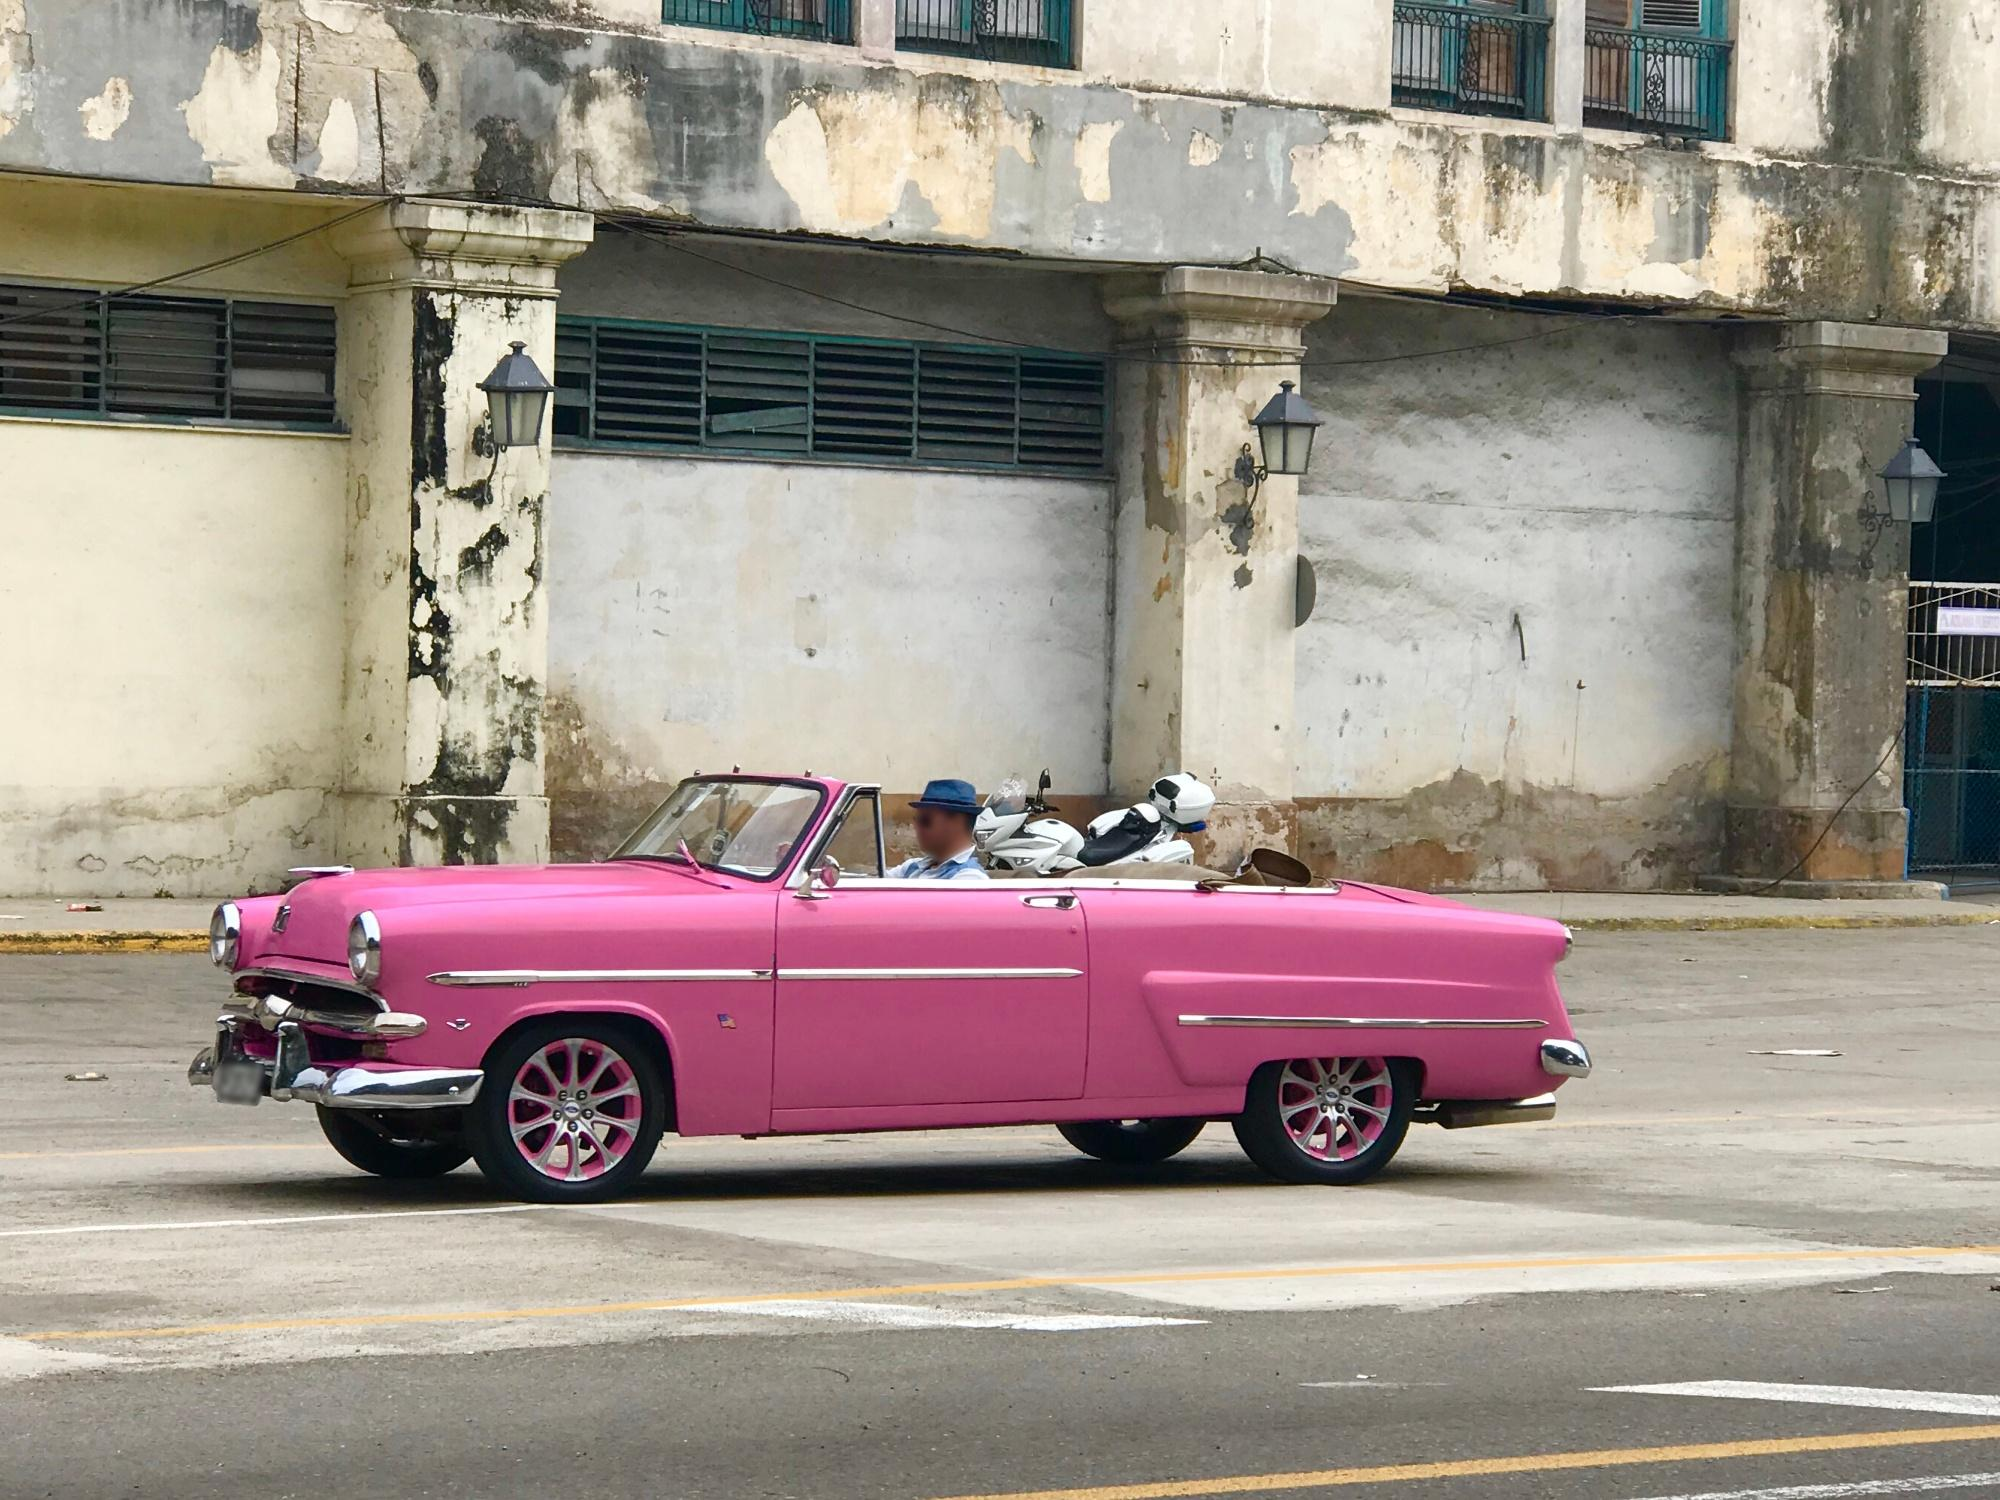Explain the visual content of the image in great detail. The image captures a scene of a vintage car parked on a street, adding a touch of nostalgia to the urban landscape. The car, a convertible, is painted in a vibrant shade of pink, contrasting with its white top. Its chrome bumper and grille, along with the pink hubcaps, reflect the attention to detail in its design. 

The car is not alone; there are two people inside, one in the driver's seat and the other in the passenger seat, perhaps ready to embark on a journey or returning from one. 

The backdrop to this scene is a dilapidated building, its white paint peeling off to reveal the passage of time. The windows of the building are boarded up, hinting at a history that remains untold. 

The perspective of the image is from the side of the car, allowing a clear view of both the car and the building behind it. The juxtaposition of the vibrant, well-maintained car against the worn-out building creates a striking contrast, making the image all the more captivating. 

As for the landmark, the information provided (sa_10198) does not correspond to any known landmarks based on my current knowledge and the search results[^1^][^2^][^3^]. Therefore, I'm unable to provide further details about the location. 